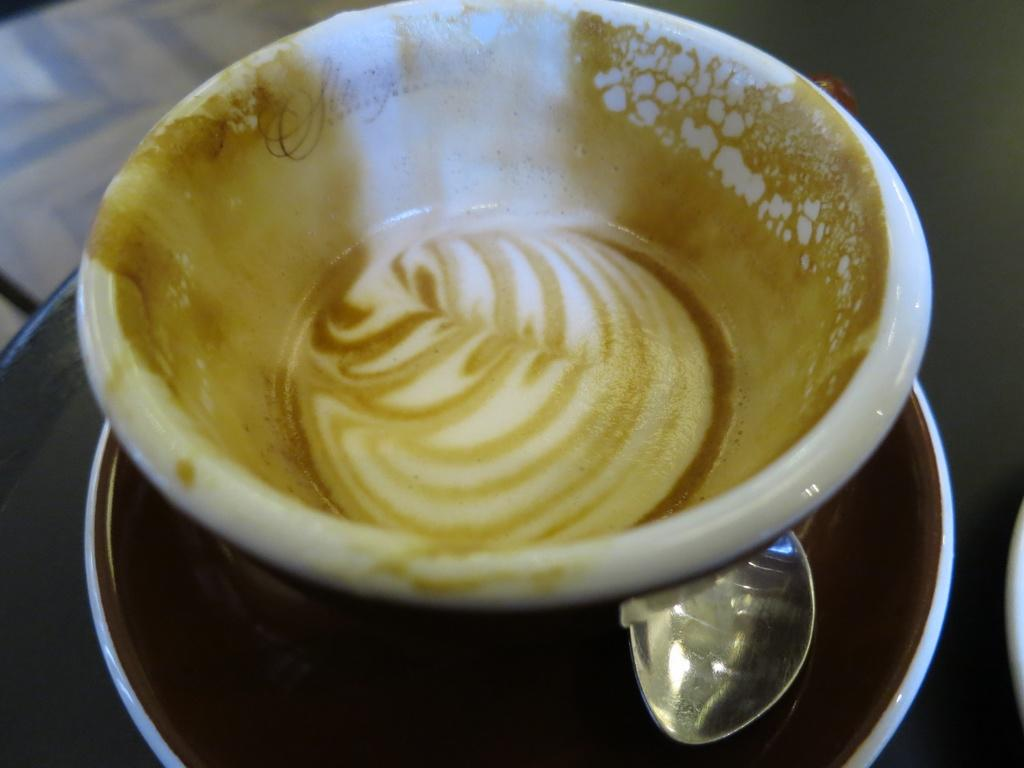What is the main object in the image? There is a coffee cup in the image. What other objects are present with the coffee cup? There is a spoon and a saucer in the image. Where are these objects located? All of these objects are on a table. How many attempts were made to balance the quartz on the coffee cup in the image? There is no quartz present in the image, and therefore no attempts were made to balance it on the coffee cup. 